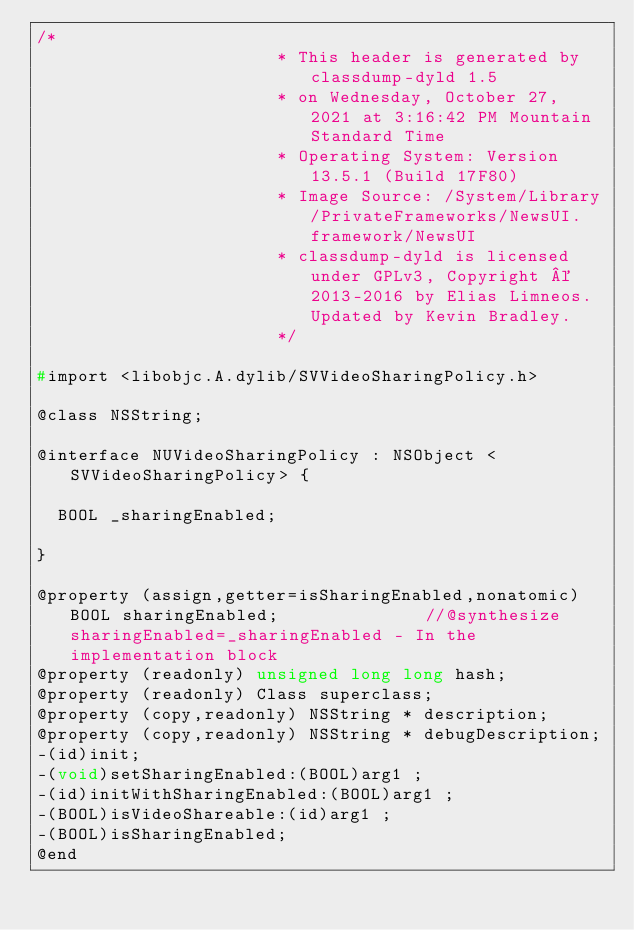<code> <loc_0><loc_0><loc_500><loc_500><_C_>/*
                       * This header is generated by classdump-dyld 1.5
                       * on Wednesday, October 27, 2021 at 3:16:42 PM Mountain Standard Time
                       * Operating System: Version 13.5.1 (Build 17F80)
                       * Image Source: /System/Library/PrivateFrameworks/NewsUI.framework/NewsUI
                       * classdump-dyld is licensed under GPLv3, Copyright © 2013-2016 by Elias Limneos. Updated by Kevin Bradley.
                       */

#import <libobjc.A.dylib/SVVideoSharingPolicy.h>

@class NSString;

@interface NUVideoSharingPolicy : NSObject <SVVideoSharingPolicy> {

	BOOL _sharingEnabled;

}

@property (assign,getter=isSharingEnabled,nonatomic) BOOL sharingEnabled;              //@synthesize sharingEnabled=_sharingEnabled - In the implementation block
@property (readonly) unsigned long long hash; 
@property (readonly) Class superclass; 
@property (copy,readonly) NSString * description; 
@property (copy,readonly) NSString * debugDescription; 
-(id)init;
-(void)setSharingEnabled:(BOOL)arg1 ;
-(id)initWithSharingEnabled:(BOOL)arg1 ;
-(BOOL)isVideoShareable:(id)arg1 ;
-(BOOL)isSharingEnabled;
@end

</code> 